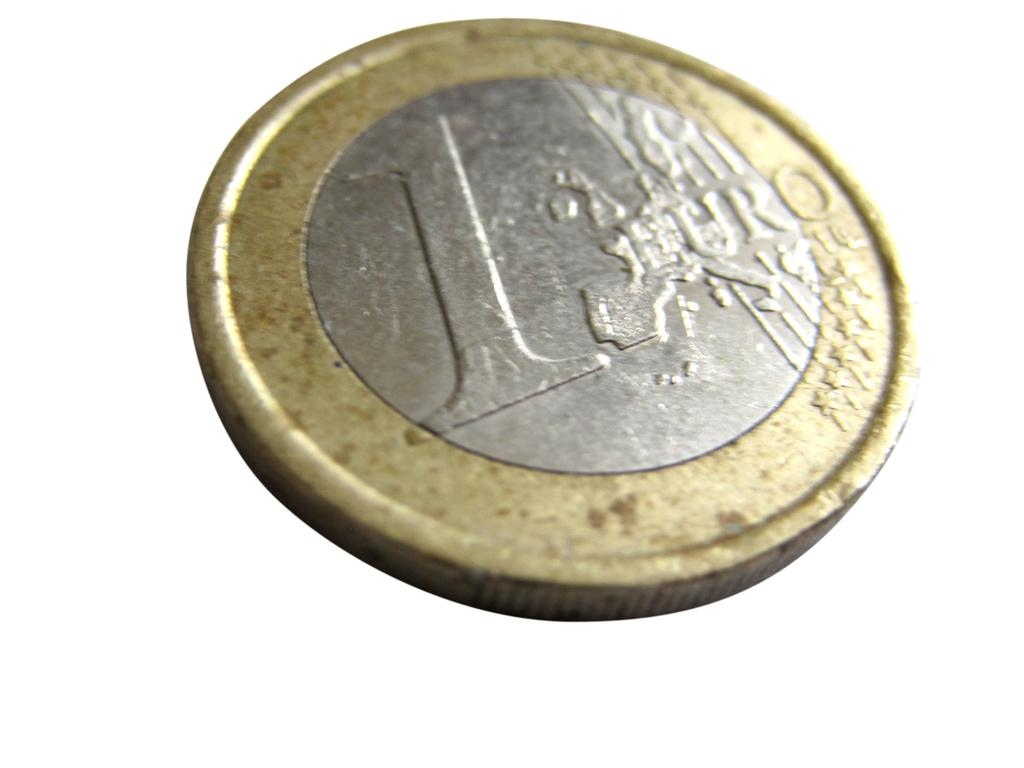<image>
Relay a brief, clear account of the picture shown. Circular metal coin with a gold rim around a silver center which contains a map of Europe and the words 1 EURO 